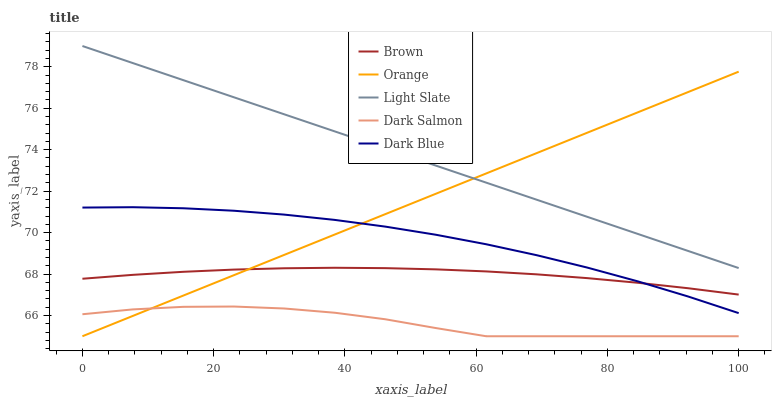Does Dark Salmon have the minimum area under the curve?
Answer yes or no. Yes. Does Light Slate have the maximum area under the curve?
Answer yes or no. Yes. Does Brown have the minimum area under the curve?
Answer yes or no. No. Does Brown have the maximum area under the curve?
Answer yes or no. No. Is Orange the smoothest?
Answer yes or no. Yes. Is Dark Salmon the roughest?
Answer yes or no. Yes. Is Brown the smoothest?
Answer yes or no. No. Is Brown the roughest?
Answer yes or no. No. Does Brown have the lowest value?
Answer yes or no. No. Does Light Slate have the highest value?
Answer yes or no. Yes. Does Brown have the highest value?
Answer yes or no. No. Is Brown less than Light Slate?
Answer yes or no. Yes. Is Light Slate greater than Dark Salmon?
Answer yes or no. Yes. Does Orange intersect Brown?
Answer yes or no. Yes. Is Orange less than Brown?
Answer yes or no. No. Is Orange greater than Brown?
Answer yes or no. No. Does Brown intersect Light Slate?
Answer yes or no. No. 